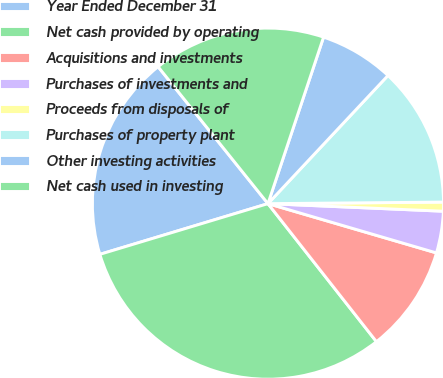Convert chart. <chart><loc_0><loc_0><loc_500><loc_500><pie_chart><fcel>Year Ended December 31<fcel>Net cash provided by operating<fcel>Acquisitions and investments<fcel>Purchases of investments and<fcel>Proceeds from disposals of<fcel>Purchases of property plant<fcel>Other investing activities<fcel>Net cash used in investing<nl><fcel>18.9%<fcel>30.94%<fcel>9.87%<fcel>3.84%<fcel>0.83%<fcel>12.88%<fcel>6.85%<fcel>15.89%<nl></chart> 